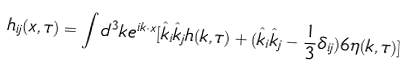<formula> <loc_0><loc_0><loc_500><loc_500>h _ { i j } ( x , \tau ) = \int d ^ { 3 } k e ^ { i k \cdot x } [ \hat { k } _ { i } \hat { k } _ { j } h ( k , \tau ) + ( \hat { k } _ { i } \hat { k } _ { j } - \frac { 1 } { 3 } \delta _ { i j } ) 6 \eta ( k , \tau ) ]</formula> 